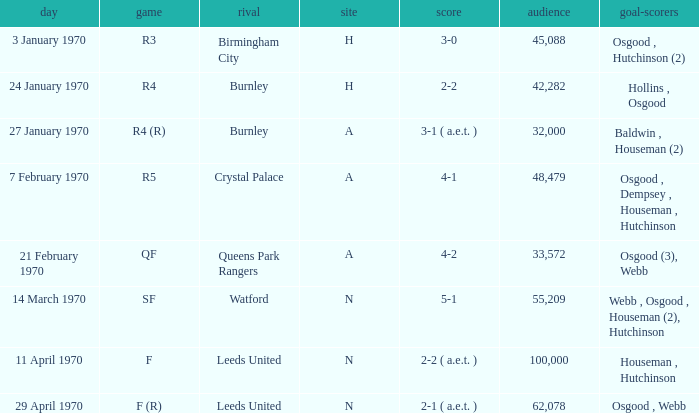What round was the game against Watford? SF. 